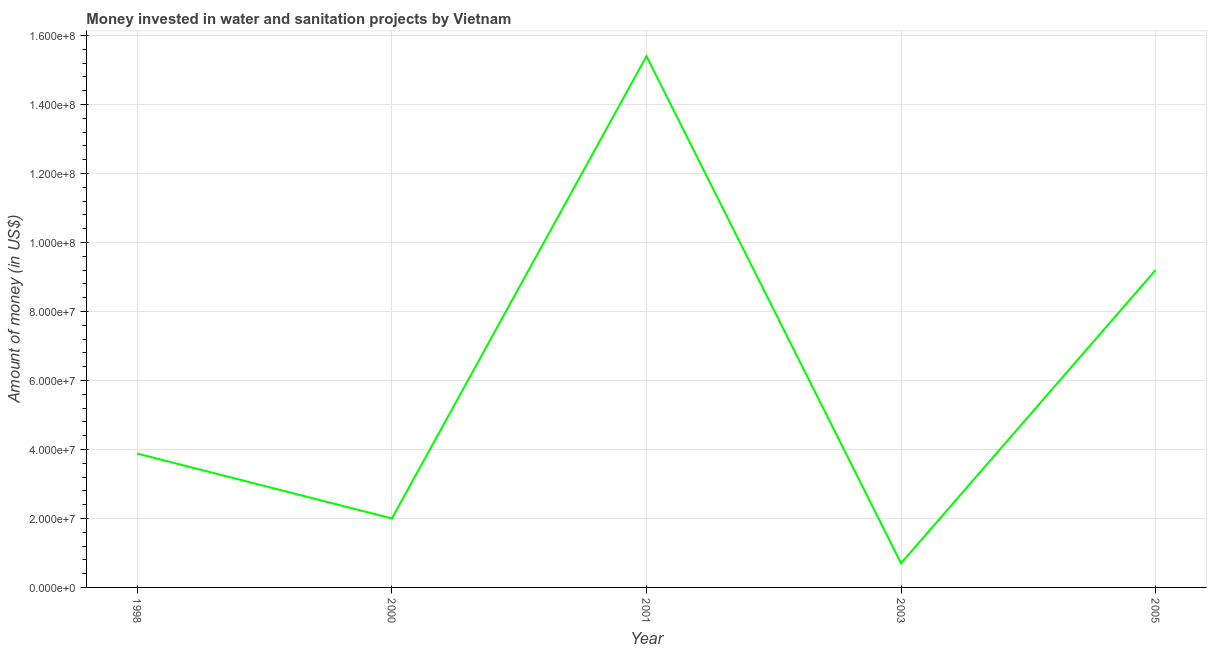What is the investment in 2003?
Provide a succinct answer. 7.00e+06. Across all years, what is the maximum investment?
Ensure brevity in your answer.  1.54e+08. Across all years, what is the minimum investment?
Your answer should be very brief. 7.00e+06. What is the sum of the investment?
Your answer should be very brief. 3.12e+08. What is the difference between the investment in 1998 and 2000?
Your answer should be compact. 1.88e+07. What is the average investment per year?
Your response must be concise. 6.24e+07. What is the median investment?
Your response must be concise. 3.88e+07. Do a majority of the years between 1998 and 2000 (inclusive) have investment greater than 68000000 US$?
Provide a short and direct response. No. What is the ratio of the investment in 1998 to that in 2005?
Ensure brevity in your answer.  0.42. Is the investment in 2001 less than that in 2003?
Your answer should be compact. No. Is the difference between the investment in 2000 and 2005 greater than the difference between any two years?
Provide a short and direct response. No. What is the difference between the highest and the second highest investment?
Your answer should be very brief. 6.20e+07. What is the difference between the highest and the lowest investment?
Make the answer very short. 1.47e+08. How many lines are there?
Offer a terse response. 1. What is the title of the graph?
Your answer should be compact. Money invested in water and sanitation projects by Vietnam. What is the label or title of the X-axis?
Your response must be concise. Year. What is the label or title of the Y-axis?
Your response must be concise. Amount of money (in US$). What is the Amount of money (in US$) of 1998?
Your response must be concise. 3.88e+07. What is the Amount of money (in US$) in 2001?
Give a very brief answer. 1.54e+08. What is the Amount of money (in US$) in 2003?
Offer a very short reply. 7.00e+06. What is the Amount of money (in US$) of 2005?
Offer a terse response. 9.20e+07. What is the difference between the Amount of money (in US$) in 1998 and 2000?
Your answer should be compact. 1.88e+07. What is the difference between the Amount of money (in US$) in 1998 and 2001?
Offer a very short reply. -1.15e+08. What is the difference between the Amount of money (in US$) in 1998 and 2003?
Provide a short and direct response. 3.18e+07. What is the difference between the Amount of money (in US$) in 1998 and 2005?
Give a very brief answer. -5.32e+07. What is the difference between the Amount of money (in US$) in 2000 and 2001?
Offer a terse response. -1.34e+08. What is the difference between the Amount of money (in US$) in 2000 and 2003?
Provide a short and direct response. 1.30e+07. What is the difference between the Amount of money (in US$) in 2000 and 2005?
Your answer should be very brief. -7.20e+07. What is the difference between the Amount of money (in US$) in 2001 and 2003?
Make the answer very short. 1.47e+08. What is the difference between the Amount of money (in US$) in 2001 and 2005?
Offer a very short reply. 6.20e+07. What is the difference between the Amount of money (in US$) in 2003 and 2005?
Offer a very short reply. -8.50e+07. What is the ratio of the Amount of money (in US$) in 1998 to that in 2000?
Ensure brevity in your answer.  1.94. What is the ratio of the Amount of money (in US$) in 1998 to that in 2001?
Your answer should be compact. 0.25. What is the ratio of the Amount of money (in US$) in 1998 to that in 2003?
Your answer should be very brief. 5.54. What is the ratio of the Amount of money (in US$) in 1998 to that in 2005?
Your answer should be compact. 0.42. What is the ratio of the Amount of money (in US$) in 2000 to that in 2001?
Offer a terse response. 0.13. What is the ratio of the Amount of money (in US$) in 2000 to that in 2003?
Ensure brevity in your answer.  2.86. What is the ratio of the Amount of money (in US$) in 2000 to that in 2005?
Provide a succinct answer. 0.22. What is the ratio of the Amount of money (in US$) in 2001 to that in 2005?
Your answer should be very brief. 1.67. What is the ratio of the Amount of money (in US$) in 2003 to that in 2005?
Ensure brevity in your answer.  0.08. 